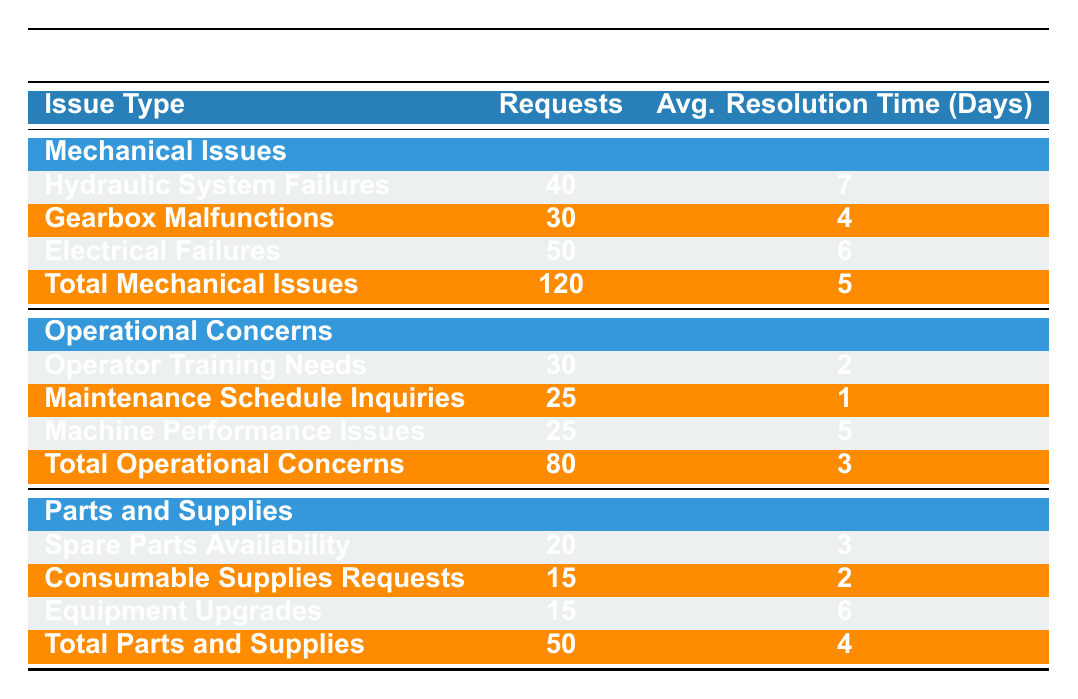What is the total number of after-sales service requests? To find the total, we sum all the requests across all issue types: 120 (Mechanical Issues) + 80 (Operational Concerns) + 50 (Parts and Supplies) = 250
Answer: 250 Which issue type has the highest number of requests? The highest requests can be found by comparing the totals for each issue type: 120 (Mechanical Issues), 80 (Operational Concerns), and 50 (Parts and Supplies). Mechanical Issues has the highest with 120 requests.
Answer: Mechanical Issues What is the average resolution time for Electrical Failures? The average resolution time for Electrical Failures is directly given in the table as 6 days.
Answer: 6 days How many requests are related to Operator Training Needs and Maintenance Schedule Inquiries combined? To get the combined requests, add the two values: 30 (Operator Training Needs) + 25 (Maintenance Schedule Inquiries) = 55.
Answer: 55 Is the average resolution time for Gearbox Malfunctions less than 5 days? The average resolution time for Gearbox Malfunctions is 4 days, which is indeed less than 5 days, satisfying the condition of the question.
Answer: Yes What is the average resolution time for all Mechanical Issues? The total resolution time for Mechanical Issues can be calculated by finding the average of the sub-issue times based on their respective requests: (7*40 + 4*30 + 6*50) / 120 = (280 + 120 + 300) / 120 = 700 / 120 = 5.83 days. However, the table shows the average directly as 5 days for all Mechanical Issues.
Answer: 5 days Which sub-issue under Parts and Supplies has the longest average resolution time? The average resolution times for the sub-issues are: Spare Parts Availability = 3 days, Consumable Supplies Requests = 2 days, Equipment Upgrades = 6 days. The longest is Equipment Upgrades, which takes 6 days on average.
Answer: Equipment Upgrades What is the total number of requests for Parts and Supplies? The total for Parts and Supplies is explicitly listed in the table as 50.
Answer: 50 Is there any sub-issue under Operational Concerns that has an average resolution time greater than 3 days? The sub-issues under Operational Concerns have average times of: Operator Training Needs = 2 days, Maintenance Schedule Inquiries = 1 day, Machine Performance Issues = 5 days. Only Machine Performance Issues exceeds 3 days, therefore the statement is true.
Answer: Yes Calculate the difference in number of requests between Mechanical Issues and Parts and Supplies. The requests for Mechanical Issues are 120 and for Parts and Supplies are 50. The difference is: 120 - 50 = 70.
Answer: 70 